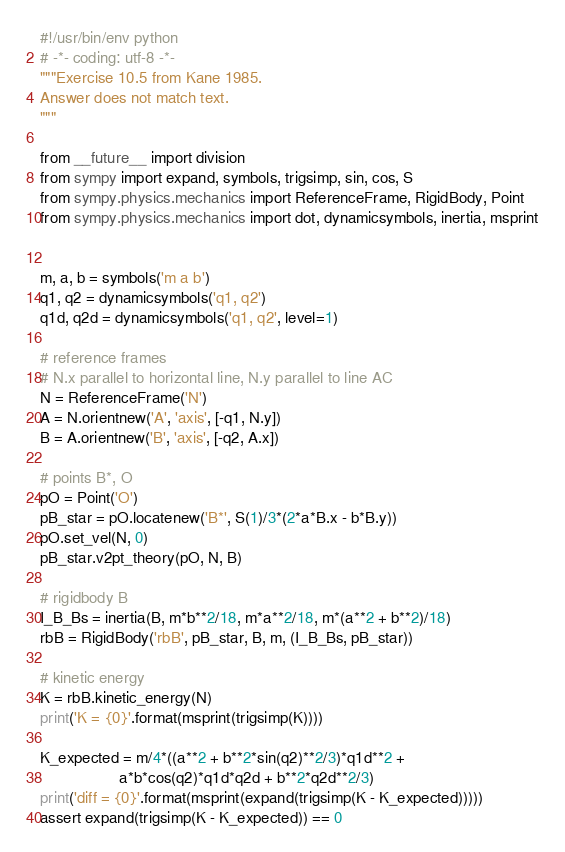<code> <loc_0><loc_0><loc_500><loc_500><_Python_>#!/usr/bin/env python
# -*- coding: utf-8 -*-
"""Exercise 10.5 from Kane 1985.
Answer does not match text.
"""

from __future__ import division
from sympy import expand, symbols, trigsimp, sin, cos, S
from sympy.physics.mechanics import ReferenceFrame, RigidBody, Point
from sympy.physics.mechanics import dot, dynamicsymbols, inertia, msprint


m, a, b = symbols('m a b')
q1, q2 = dynamicsymbols('q1, q2')
q1d, q2d = dynamicsymbols('q1, q2', level=1)

# reference frames
# N.x parallel to horizontal line, N.y parallel to line AC
N = ReferenceFrame('N')
A = N.orientnew('A', 'axis', [-q1, N.y])
B = A.orientnew('B', 'axis', [-q2, A.x])

# points B*, O
pO = Point('O')
pB_star = pO.locatenew('B*', S(1)/3*(2*a*B.x - b*B.y))
pO.set_vel(N, 0)
pB_star.v2pt_theory(pO, N, B)

# rigidbody B
I_B_Bs = inertia(B, m*b**2/18, m*a**2/18, m*(a**2 + b**2)/18)
rbB = RigidBody('rbB', pB_star, B, m, (I_B_Bs, pB_star))

# kinetic energy
K = rbB.kinetic_energy(N)
print('K = {0}'.format(msprint(trigsimp(K))))

K_expected = m/4*((a**2 + b**2*sin(q2)**2/3)*q1d**2 +
                  a*b*cos(q2)*q1d*q2d + b**2*q2d**2/3)
print('diff = {0}'.format(msprint(expand(trigsimp(K - K_expected)))))
assert expand(trigsimp(K - K_expected)) == 0
</code> 